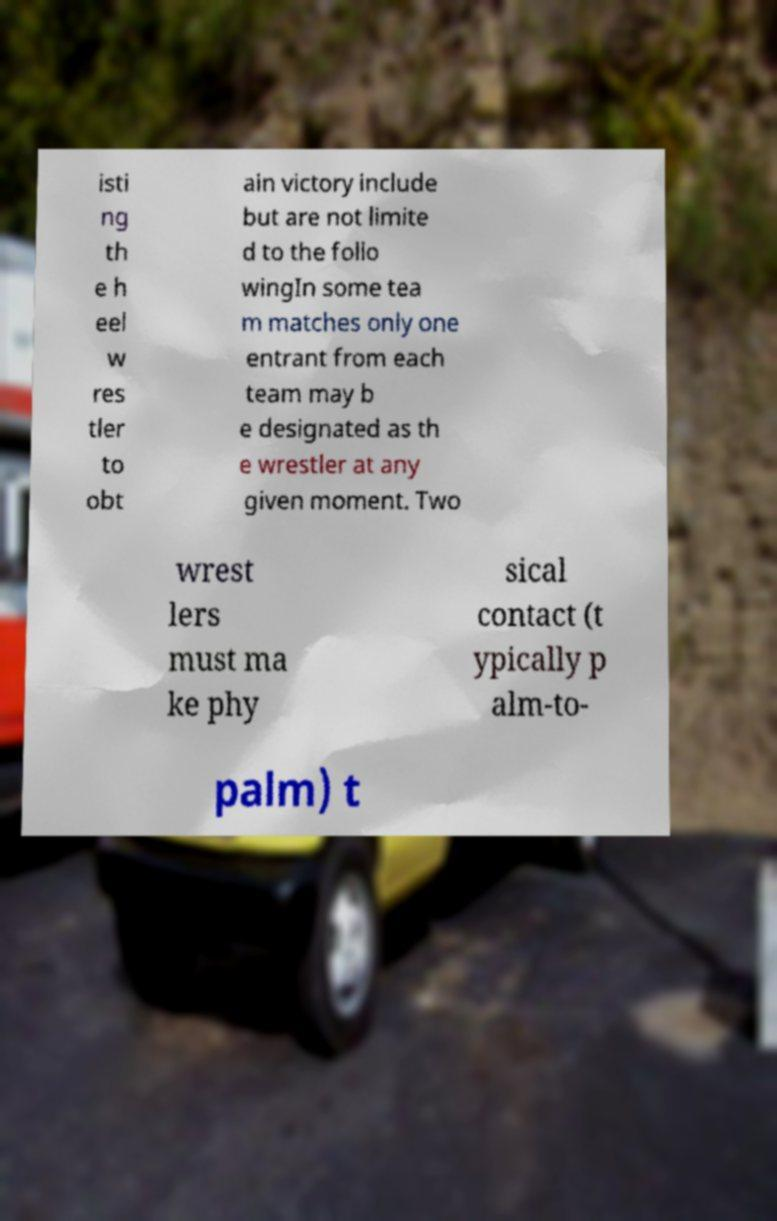Please identify and transcribe the text found in this image. isti ng th e h eel w res tler to obt ain victory include but are not limite d to the follo wingIn some tea m matches only one entrant from each team may b e designated as th e wrestler at any given moment. Two wrest lers must ma ke phy sical contact (t ypically p alm-to- palm) t 